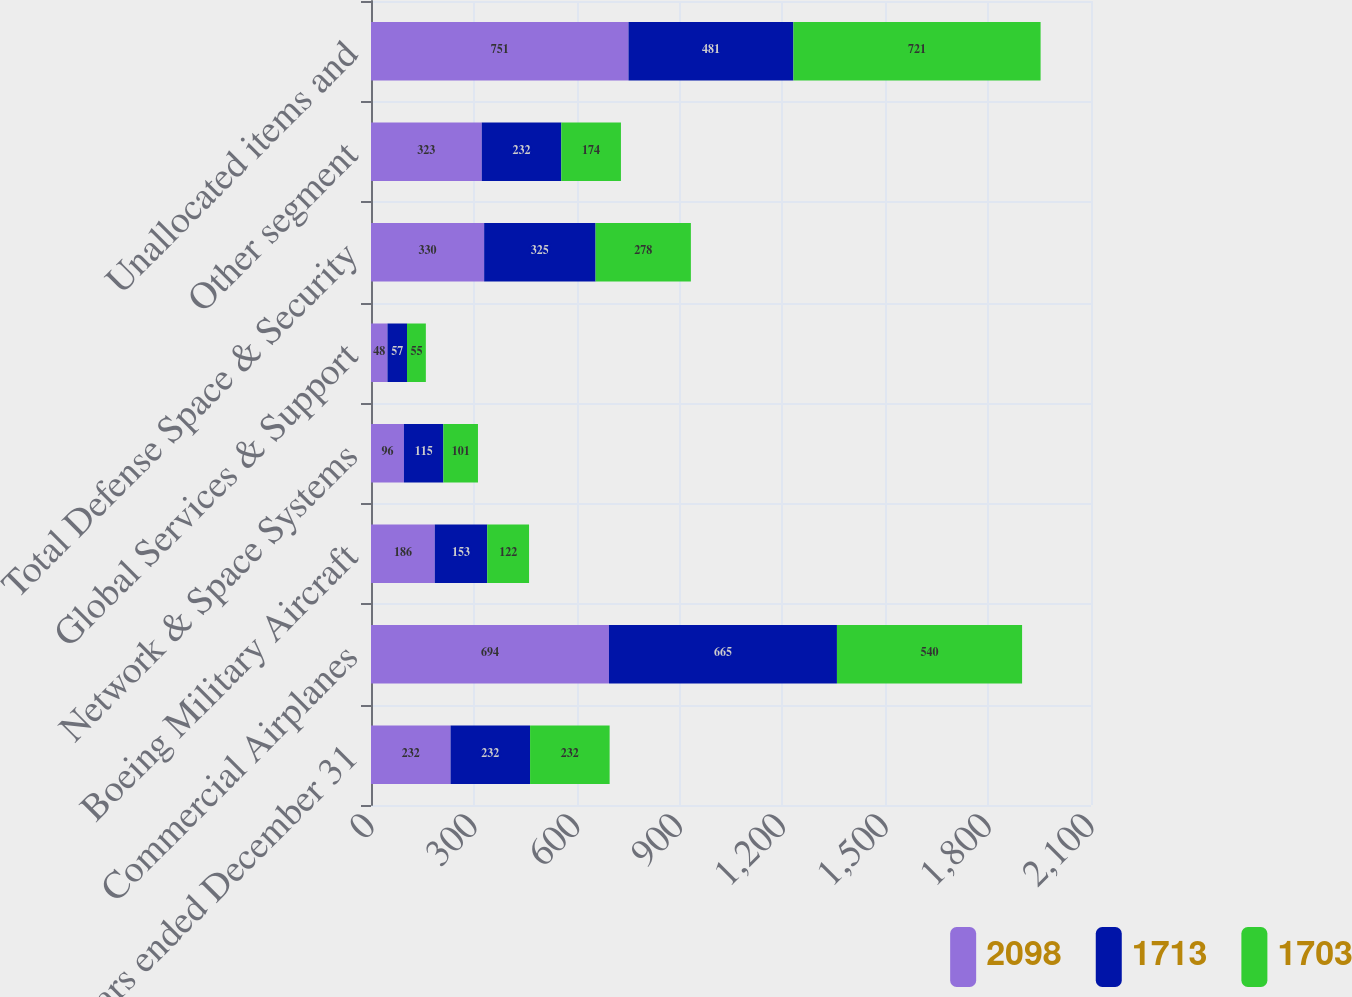Convert chart. <chart><loc_0><loc_0><loc_500><loc_500><stacked_bar_chart><ecel><fcel>Years ended December 31<fcel>Commercial Airplanes<fcel>Boeing Military Aircraft<fcel>Network & Space Systems<fcel>Global Services & Support<fcel>Total Defense Space & Security<fcel>Other segment<fcel>Unallocated items and<nl><fcel>2098<fcel>232<fcel>694<fcel>186<fcel>96<fcel>48<fcel>330<fcel>323<fcel>751<nl><fcel>1713<fcel>232<fcel>665<fcel>153<fcel>115<fcel>57<fcel>325<fcel>232<fcel>481<nl><fcel>1703<fcel>232<fcel>540<fcel>122<fcel>101<fcel>55<fcel>278<fcel>174<fcel>721<nl></chart> 